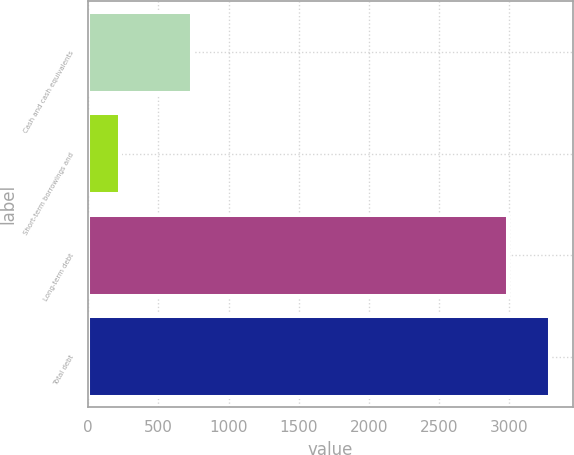<chart> <loc_0><loc_0><loc_500><loc_500><bar_chart><fcel>Cash and cash equivalents<fcel>Short-term borrowings and<fcel>Long-term debt<fcel>Total debt<nl><fcel>740<fcel>228<fcel>2990<fcel>3289<nl></chart> 